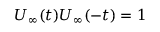Convert formula to latex. <formula><loc_0><loc_0><loc_500><loc_500>U _ { \infty } ( t ) U _ { \infty } ( - t ) = 1</formula> 